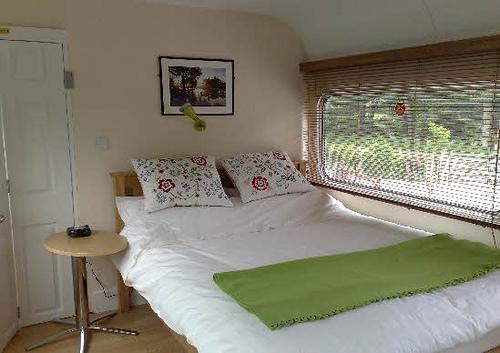How many pillows?
Give a very brief answer. 2. How many folded blankets?
Give a very brief answer. 1. 